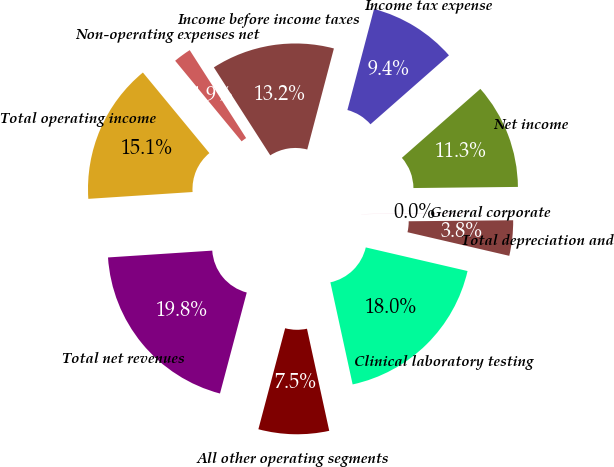<chart> <loc_0><loc_0><loc_500><loc_500><pie_chart><fcel>Clinical laboratory testing<fcel>All other operating segments<fcel>Total net revenues<fcel>Total operating income<fcel>Non-operating expenses net<fcel>Income before income taxes<fcel>Income tax expense<fcel>Net income<fcel>General corporate<fcel>Total depreciation and<nl><fcel>17.95%<fcel>7.54%<fcel>19.83%<fcel>15.06%<fcel>1.9%<fcel>13.18%<fcel>9.42%<fcel>11.3%<fcel>0.02%<fcel>3.78%<nl></chart> 